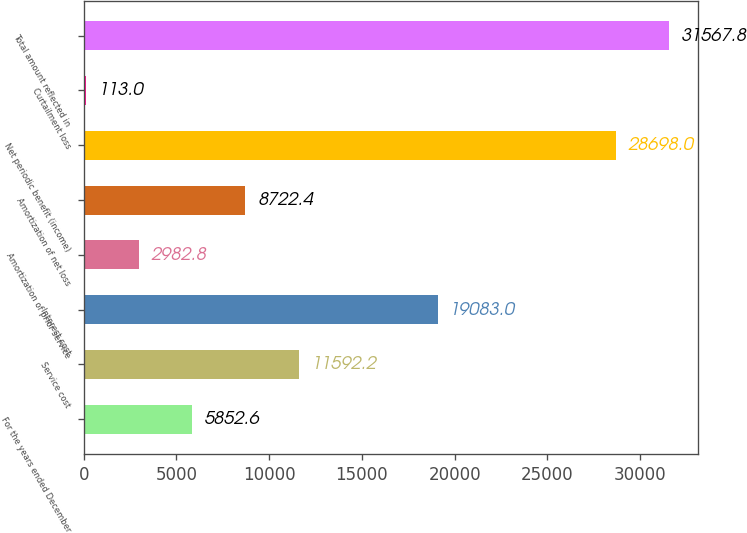Convert chart. <chart><loc_0><loc_0><loc_500><loc_500><bar_chart><fcel>For the years ended December<fcel>Service cost<fcel>Interest cost<fcel>Amortization of prior service<fcel>Amortization of net loss<fcel>Net periodic benefit (income)<fcel>Curtailment loss<fcel>Total amount reflected in<nl><fcel>5852.6<fcel>11592.2<fcel>19083<fcel>2982.8<fcel>8722.4<fcel>28698<fcel>113<fcel>31567.8<nl></chart> 